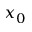Convert formula to latex. <formula><loc_0><loc_0><loc_500><loc_500>x _ { 0 }</formula> 